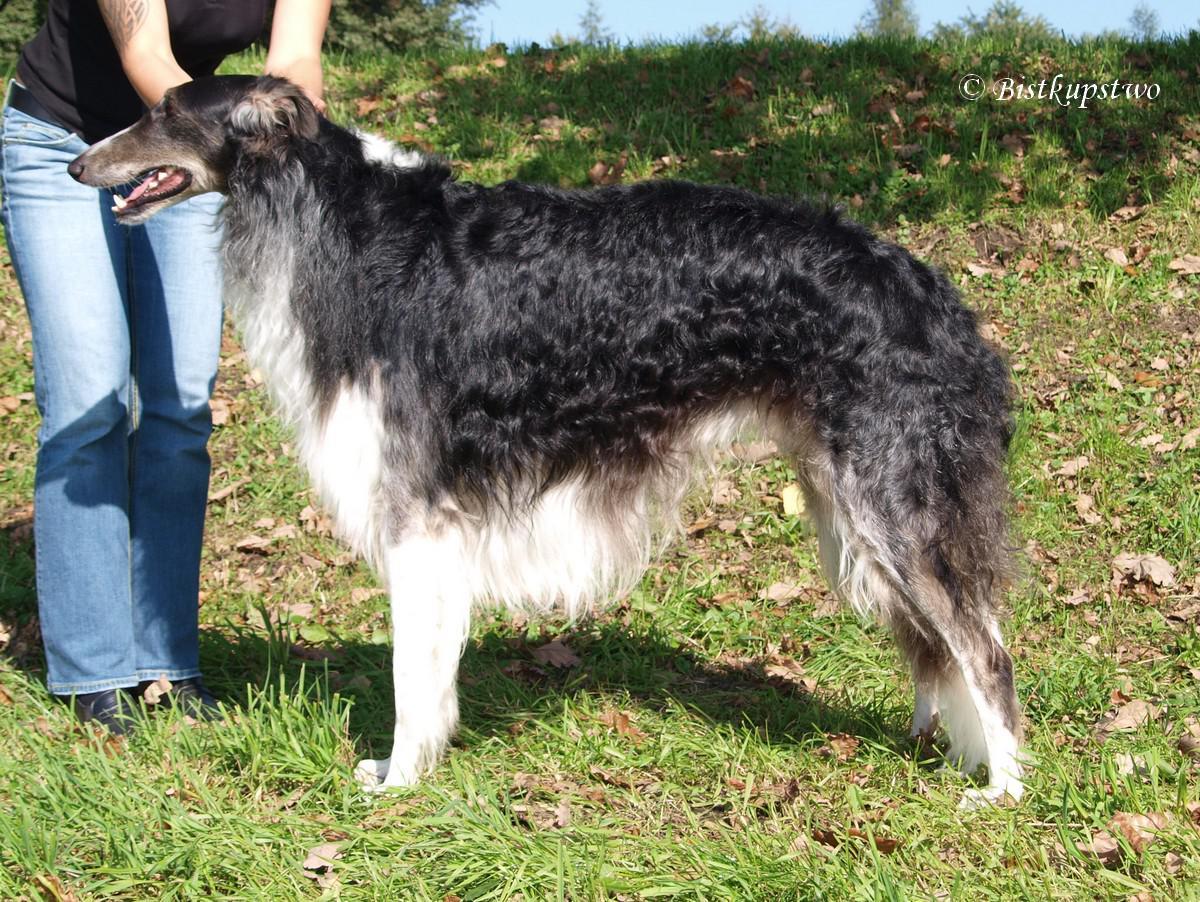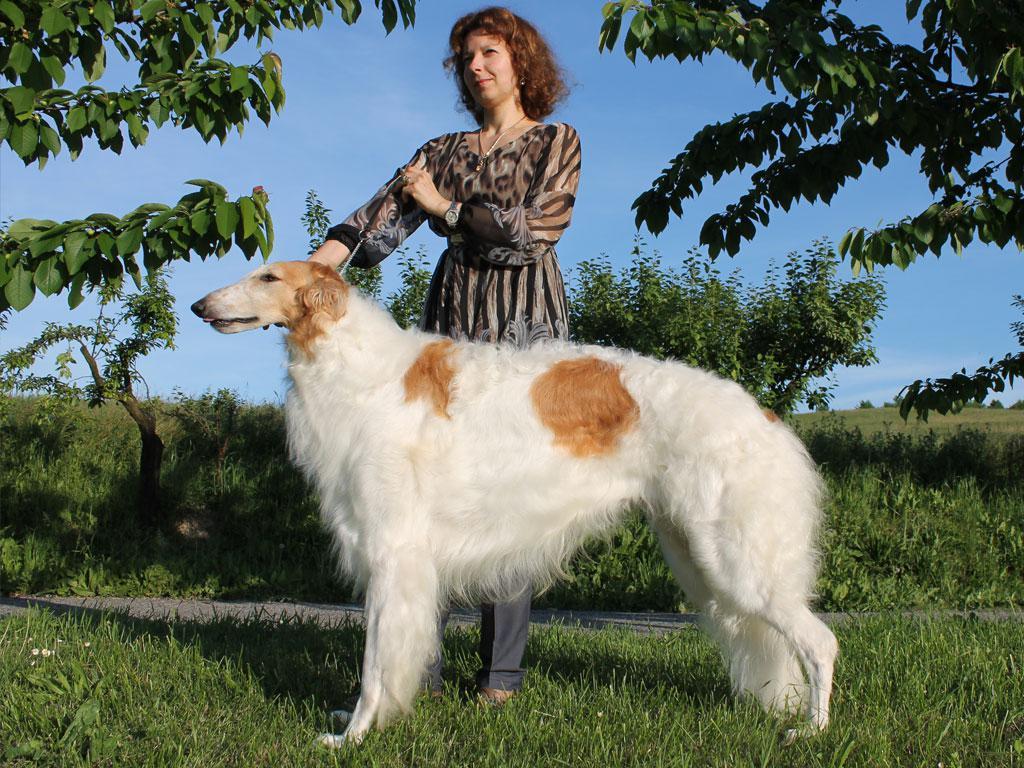The first image is the image on the left, the second image is the image on the right. Considering the images on both sides, is "There is at least 1 black and white dog that is not facing right." valid? Answer yes or no. Yes. The first image is the image on the left, the second image is the image on the right. Given the left and right images, does the statement "A long-haired dog with a thin face is standing with no other dogs." hold true? Answer yes or no. Yes. 